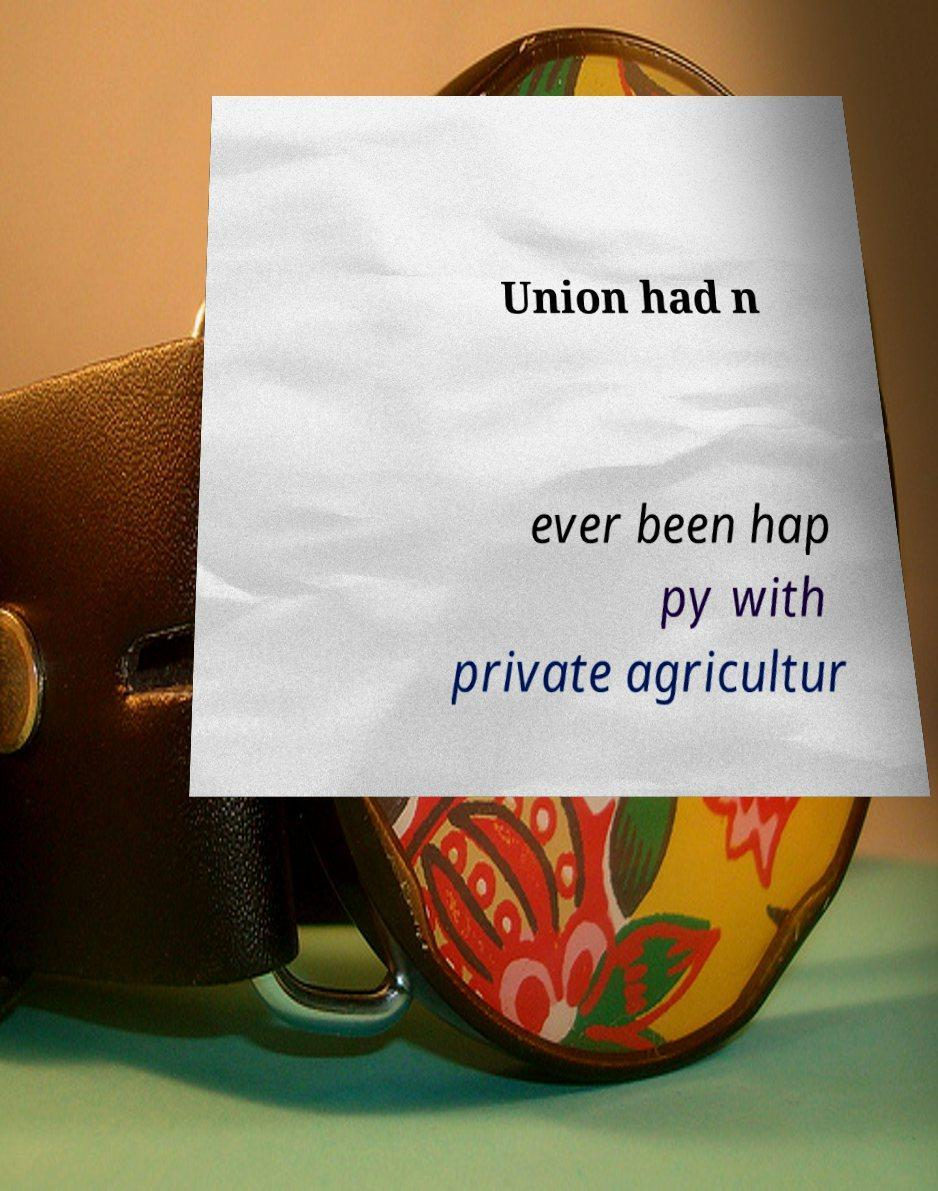What messages or text are displayed in this image? I need them in a readable, typed format. Union had n ever been hap py with private agricultur 